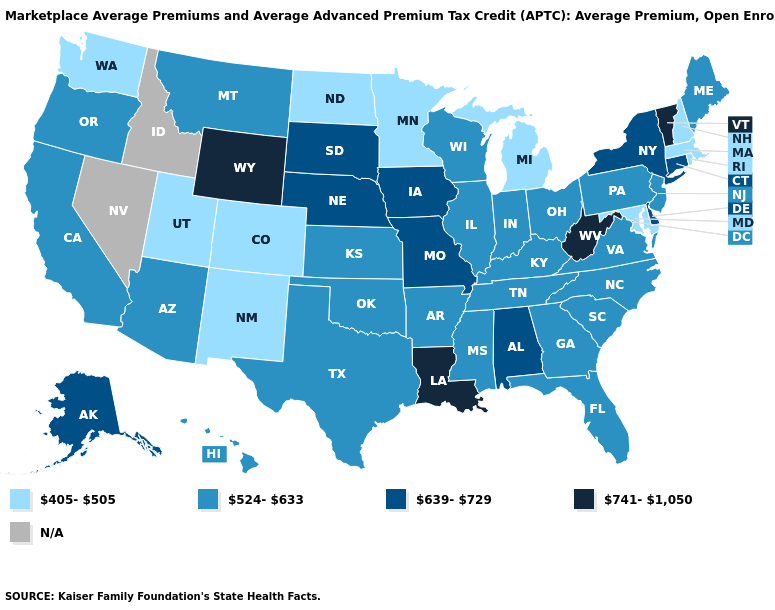Which states hav the highest value in the West?
Be succinct. Wyoming. Among the states that border Iowa , which have the highest value?
Answer briefly. Missouri, Nebraska, South Dakota. Does West Virginia have the highest value in the USA?
Write a very short answer. Yes. Does Maine have the lowest value in the USA?
Short answer required. No. What is the value of Iowa?
Write a very short answer. 639-729. Does the map have missing data?
Concise answer only. Yes. What is the lowest value in states that border California?
Short answer required. 524-633. How many symbols are there in the legend?
Quick response, please. 5. Name the states that have a value in the range 639-729?
Concise answer only. Alabama, Alaska, Connecticut, Delaware, Iowa, Missouri, Nebraska, New York, South Dakota. Does the map have missing data?
Keep it brief. Yes. What is the highest value in states that border Montana?
Give a very brief answer. 741-1,050. How many symbols are there in the legend?
Concise answer only. 5. Does Washington have the highest value in the USA?
Be succinct. No. 